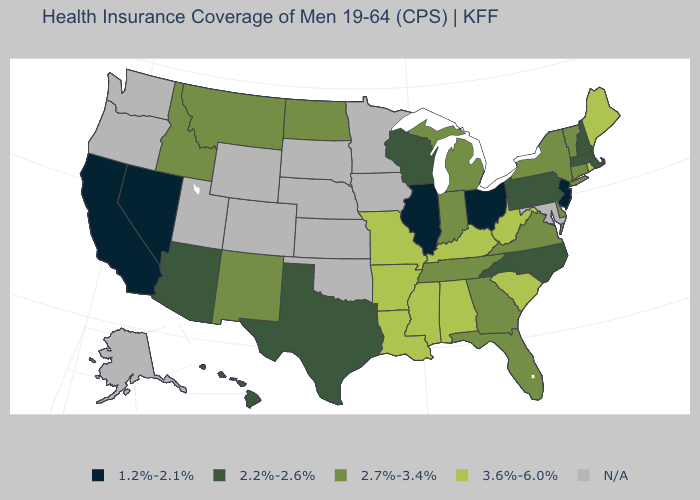Name the states that have a value in the range 2.2%-2.6%?
Answer briefly. Arizona, Hawaii, Massachusetts, New Hampshire, North Carolina, Pennsylvania, Texas, Wisconsin. Which states have the highest value in the USA?
Concise answer only. Alabama, Arkansas, Kentucky, Louisiana, Maine, Mississippi, Missouri, Rhode Island, South Carolina, West Virginia. Does Nevada have the lowest value in the West?
Give a very brief answer. Yes. What is the value of Louisiana?
Write a very short answer. 3.6%-6.0%. What is the value of Minnesota?
Keep it brief. N/A. Name the states that have a value in the range 3.6%-6.0%?
Answer briefly. Alabama, Arkansas, Kentucky, Louisiana, Maine, Mississippi, Missouri, Rhode Island, South Carolina, West Virginia. Does New Jersey have the lowest value in the USA?
Give a very brief answer. Yes. Does New Mexico have the lowest value in the USA?
Be succinct. No. Name the states that have a value in the range 2.7%-3.4%?
Short answer required. Connecticut, Delaware, Florida, Georgia, Idaho, Indiana, Michigan, Montana, New Mexico, New York, North Dakota, Tennessee, Vermont, Virginia. What is the value of Illinois?
Keep it brief. 1.2%-2.1%. Does Louisiana have the highest value in the South?
Answer briefly. Yes. What is the value of South Dakota?
Quick response, please. N/A. Does Alabama have the highest value in the USA?
Give a very brief answer. Yes. Name the states that have a value in the range N/A?
Concise answer only. Alaska, Colorado, Iowa, Kansas, Maryland, Minnesota, Nebraska, Oklahoma, Oregon, South Dakota, Utah, Washington, Wyoming. 